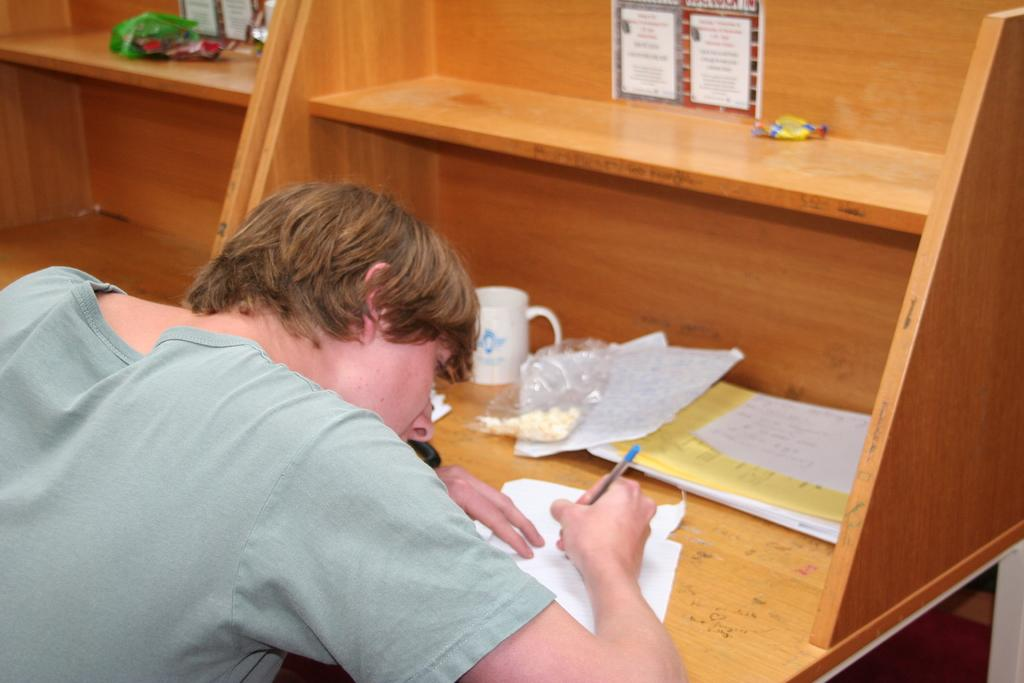What is the main subject of the image? There is a man in the image. What is the man doing in the image? The man is sitting and writing on a paper. What is the man wearing in the image? The man is wearing a green t-shirt. What can be seen on the desk in the image? There is a wooden desk in the image, with papers and a mug present on it. What type of street can be seen in the image? There is no street present in the image; it features a man sitting at a desk. What kind of market is visible in the image? There is no market present in the image; it features a man sitting at a desk. 